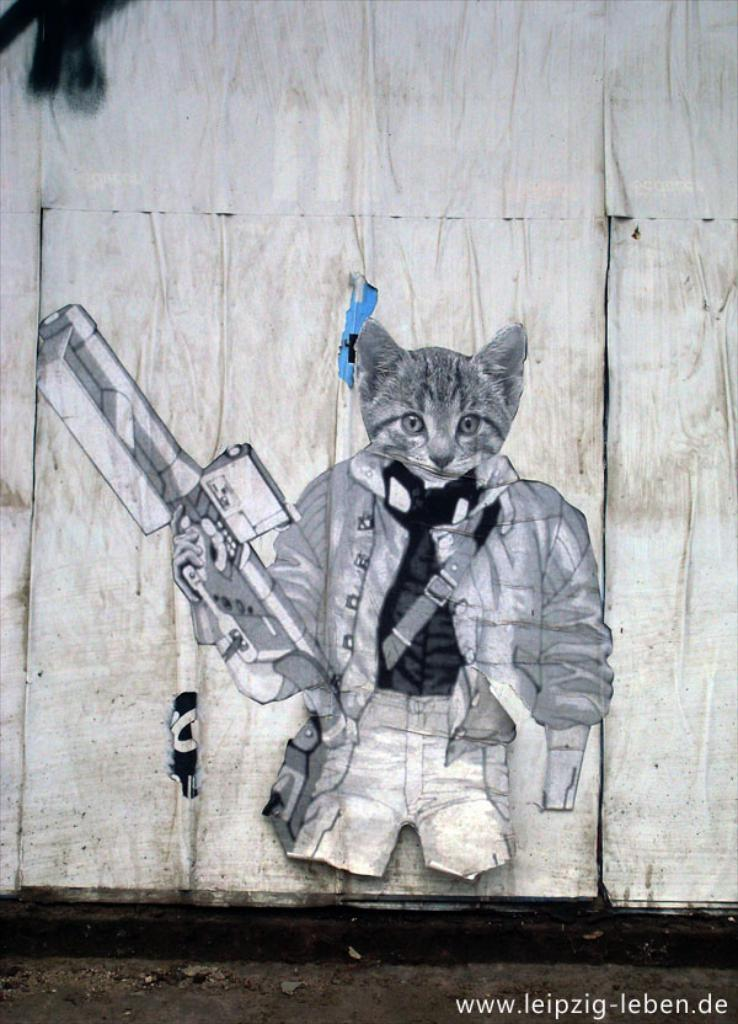What can be seen on the wall in the image? There is a sketch on the wall in the image. What is visible at the bottom of the image? There is a path visible at the bottom of the image. What type of information is present in the image? There is text present in the image. What type of current can be seen flowing through the sketch in the image? There is no current visible in the image; it is a sketch on the wall. How many fowl are present in the image? There are no fowl present in the image; it features a sketch, a path, and text. 